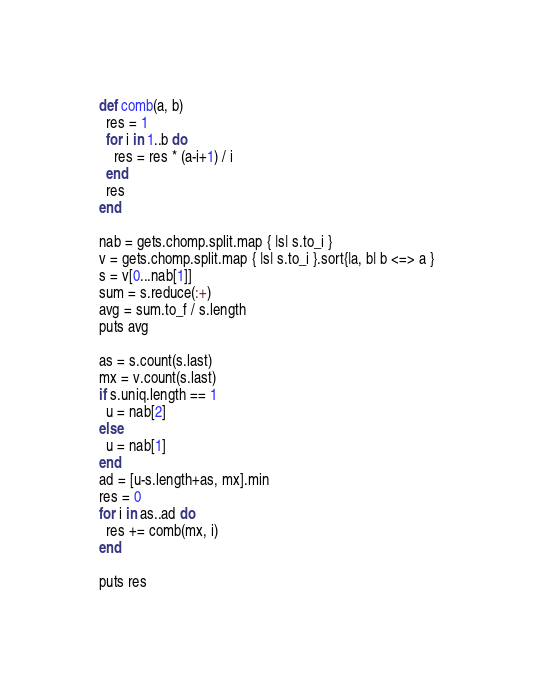<code> <loc_0><loc_0><loc_500><loc_500><_Ruby_>def comb(a, b)
  res = 1
  for i in 1..b do
    res = res * (a-i+1) / i
  end
  res
end

nab = gets.chomp.split.map { |s| s.to_i }
v = gets.chomp.split.map { |s| s.to_i }.sort{|a, b| b <=> a }
s = v[0...nab[1]]
sum = s.reduce(:+)
avg = sum.to_f / s.length
puts avg

as = s.count(s.last)
mx = v.count(s.last)
if s.uniq.length == 1
  u = nab[2]
else
  u = nab[1]
end
ad = [u-s.length+as, mx].min
res = 0
for i in as..ad do
  res += comb(mx, i)
end

puts res</code> 